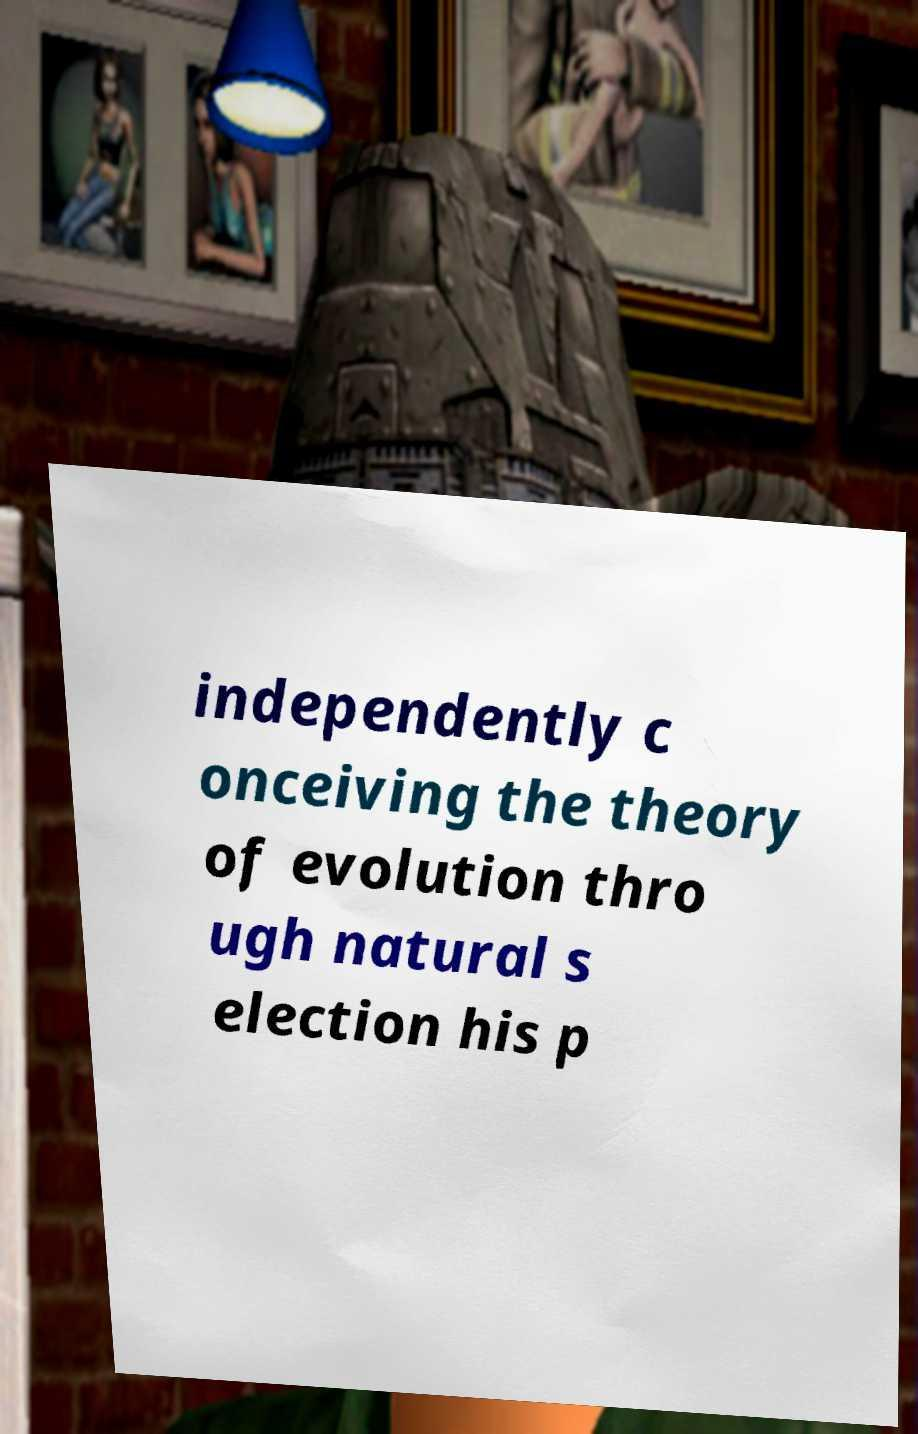Can you accurately transcribe the text from the provided image for me? independently c onceiving the theory of evolution thro ugh natural s election his p 